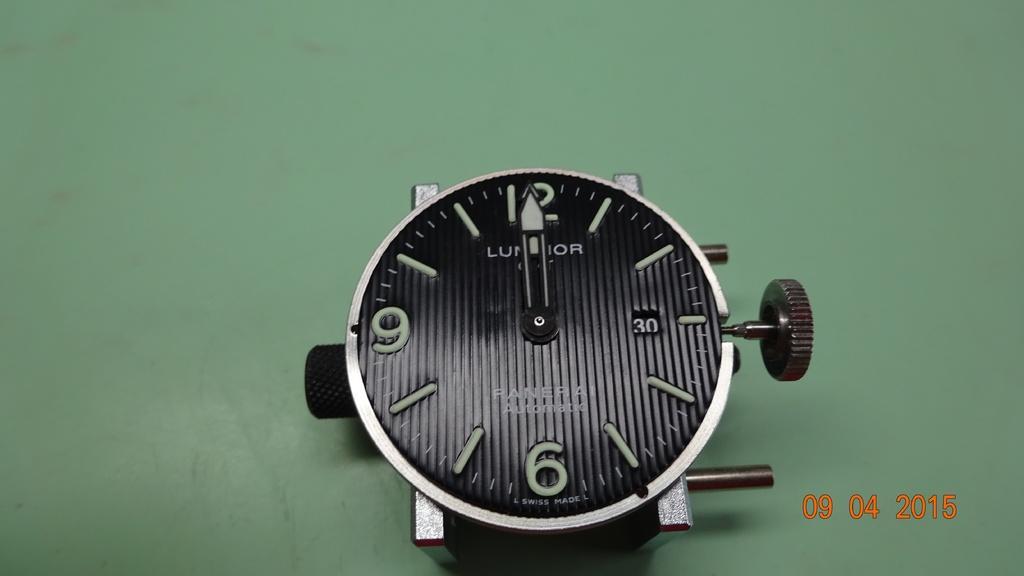Can you describe this image briefly? In this image we can see a clock's dial on the surface. 